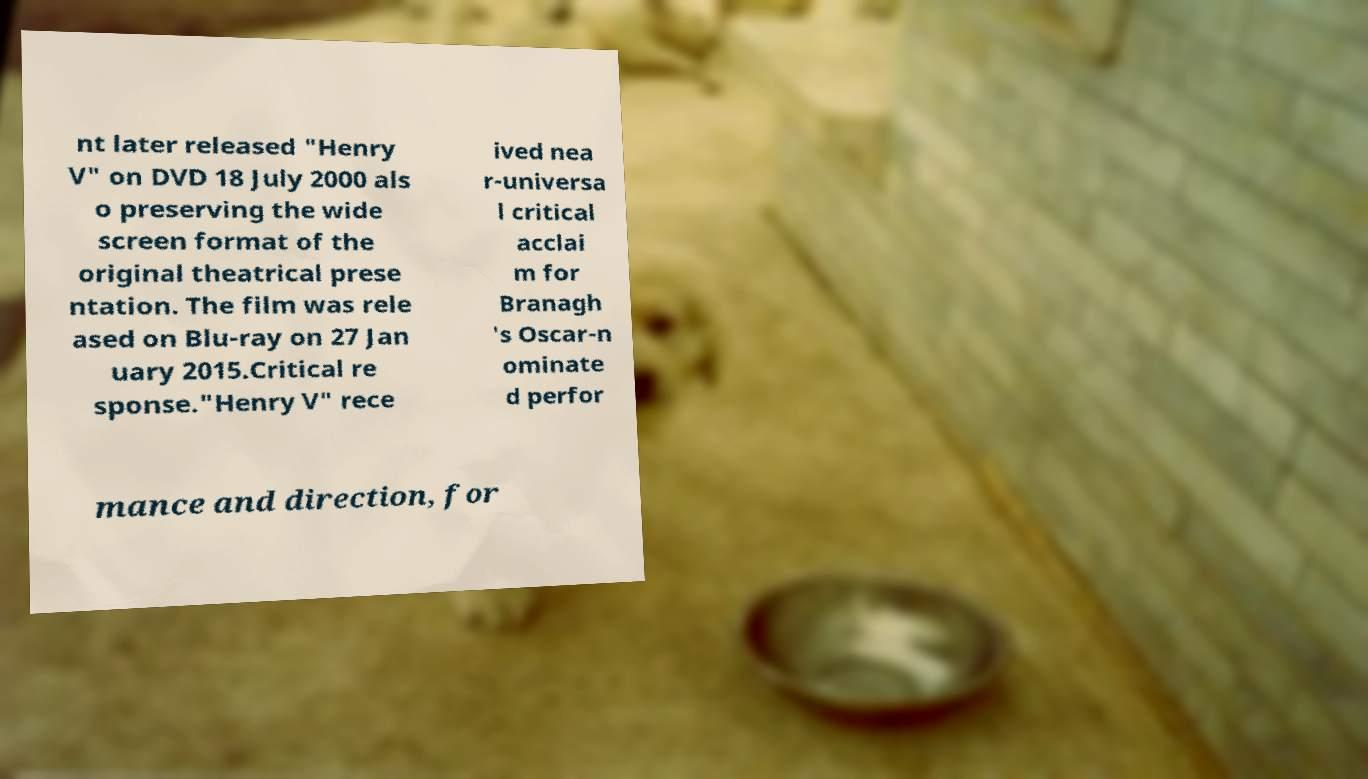What messages or text are displayed in this image? I need them in a readable, typed format. nt later released "Henry V" on DVD 18 July 2000 als o preserving the wide screen format of the original theatrical prese ntation. The film was rele ased on Blu-ray on 27 Jan uary 2015.Critical re sponse."Henry V" rece ived nea r-universa l critical acclai m for Branagh 's Oscar-n ominate d perfor mance and direction, for 